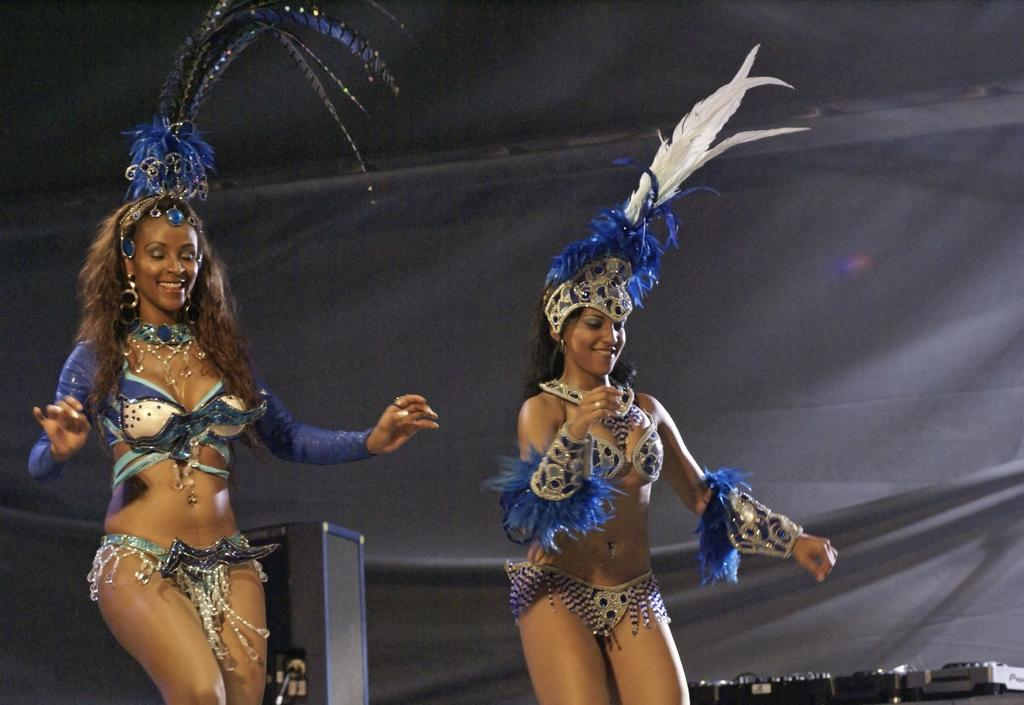How many women are in the image? There are two women in the image. What are the women wearing? The women are wearing different costumes. What are the women doing in the image? The women are dancing. What expressions do the women have on their faces? The women are smiling. What can be seen in the background of the image? There is a black color cover in the background of the image, and a few objects are visible. What type of punishment is being given to the women in the image? There is no indication of punishment in the image; the women are dancing and smiling. How many cows are present on the farm in the image? There is no farm or cows present in the image; it features two women dancing. 